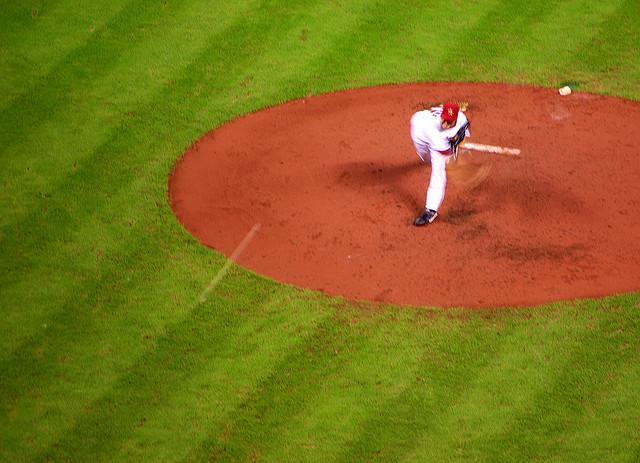How many people are there?
Give a very brief answer. 1. 